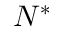Convert formula to latex. <formula><loc_0><loc_0><loc_500><loc_500>N ^ { * }</formula> 